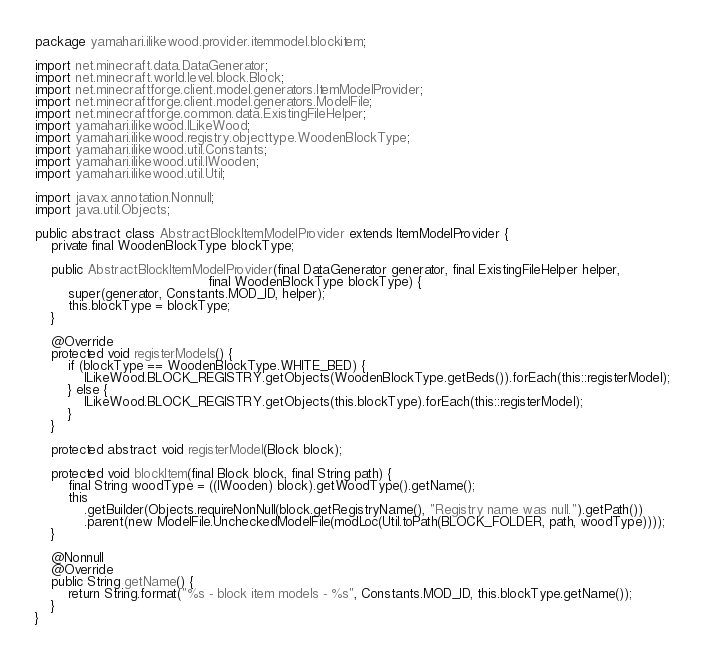Convert code to text. <code><loc_0><loc_0><loc_500><loc_500><_Java_>package yamahari.ilikewood.provider.itemmodel.blockitem;

import net.minecraft.data.DataGenerator;
import net.minecraft.world.level.block.Block;
import net.minecraftforge.client.model.generators.ItemModelProvider;
import net.minecraftforge.client.model.generators.ModelFile;
import net.minecraftforge.common.data.ExistingFileHelper;
import yamahari.ilikewood.ILikeWood;
import yamahari.ilikewood.registry.objecttype.WoodenBlockType;
import yamahari.ilikewood.util.Constants;
import yamahari.ilikewood.util.IWooden;
import yamahari.ilikewood.util.Util;

import javax.annotation.Nonnull;
import java.util.Objects;

public abstract class AbstractBlockItemModelProvider extends ItemModelProvider {
    private final WoodenBlockType blockType;

    public AbstractBlockItemModelProvider(final DataGenerator generator, final ExistingFileHelper helper,
                                          final WoodenBlockType blockType) {
        super(generator, Constants.MOD_ID, helper);
        this.blockType = blockType;
    }

    @Override
    protected void registerModels() {
        if (blockType == WoodenBlockType.WHITE_BED) {
            ILikeWood.BLOCK_REGISTRY.getObjects(WoodenBlockType.getBeds()).forEach(this::registerModel);
        } else {
            ILikeWood.BLOCK_REGISTRY.getObjects(this.blockType).forEach(this::registerModel);
        }
    }

    protected abstract void registerModel(Block block);

    protected void blockItem(final Block block, final String path) {
        final String woodType = ((IWooden) block).getWoodType().getName();
        this
            .getBuilder(Objects.requireNonNull(block.getRegistryName(), "Registry name was null.").getPath())
            .parent(new ModelFile.UncheckedModelFile(modLoc(Util.toPath(BLOCK_FOLDER, path, woodType))));
    }

    @Nonnull
    @Override
    public String getName() {
        return String.format("%s - block item models - %s", Constants.MOD_ID, this.blockType.getName());
    }
}
</code> 